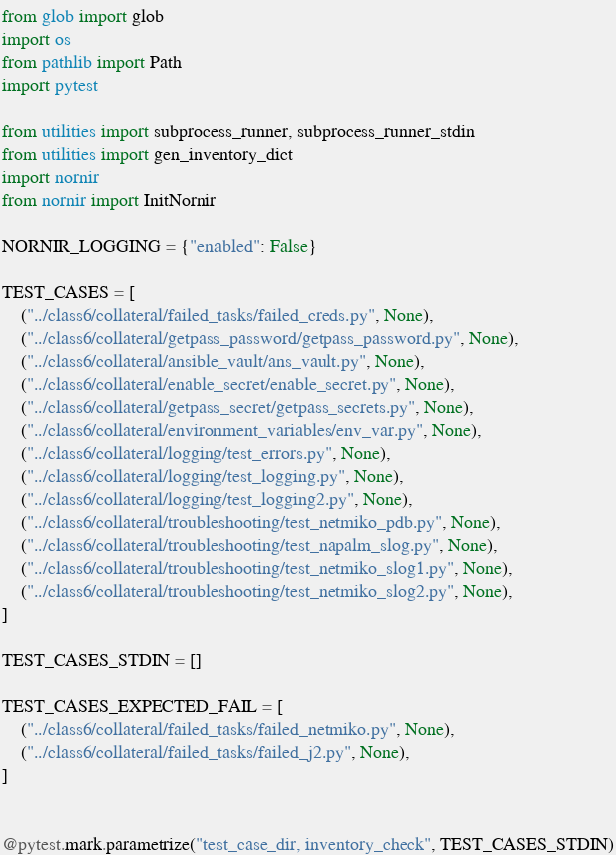Convert code to text. <code><loc_0><loc_0><loc_500><loc_500><_Python_>from glob import glob
import os
from pathlib import Path
import pytest

from utilities import subprocess_runner, subprocess_runner_stdin
from utilities import gen_inventory_dict
import nornir
from nornir import InitNornir

NORNIR_LOGGING = {"enabled": False}

TEST_CASES = [
    ("../class6/collateral/failed_tasks/failed_creds.py", None),
    ("../class6/collateral/getpass_password/getpass_password.py", None),
    ("../class6/collateral/ansible_vault/ans_vault.py", None),
    ("../class6/collateral/enable_secret/enable_secret.py", None),
    ("../class6/collateral/getpass_secret/getpass_secrets.py", None),
    ("../class6/collateral/environment_variables/env_var.py", None),
    ("../class6/collateral/logging/test_errors.py", None),
    ("../class6/collateral/logging/test_logging.py", None),
    ("../class6/collateral/logging/test_logging2.py", None),
    ("../class6/collateral/troubleshooting/test_netmiko_pdb.py", None),
    ("../class6/collateral/troubleshooting/test_napalm_slog.py", None),
    ("../class6/collateral/troubleshooting/test_netmiko_slog1.py", None),
    ("../class6/collateral/troubleshooting/test_netmiko_slog2.py", None),
]

TEST_CASES_STDIN = []

TEST_CASES_EXPECTED_FAIL = [
    ("../class6/collateral/failed_tasks/failed_netmiko.py", None),
    ("../class6/collateral/failed_tasks/failed_j2.py", None),
]


@pytest.mark.parametrize("test_case_dir, inventory_check", TEST_CASES_STDIN)</code> 